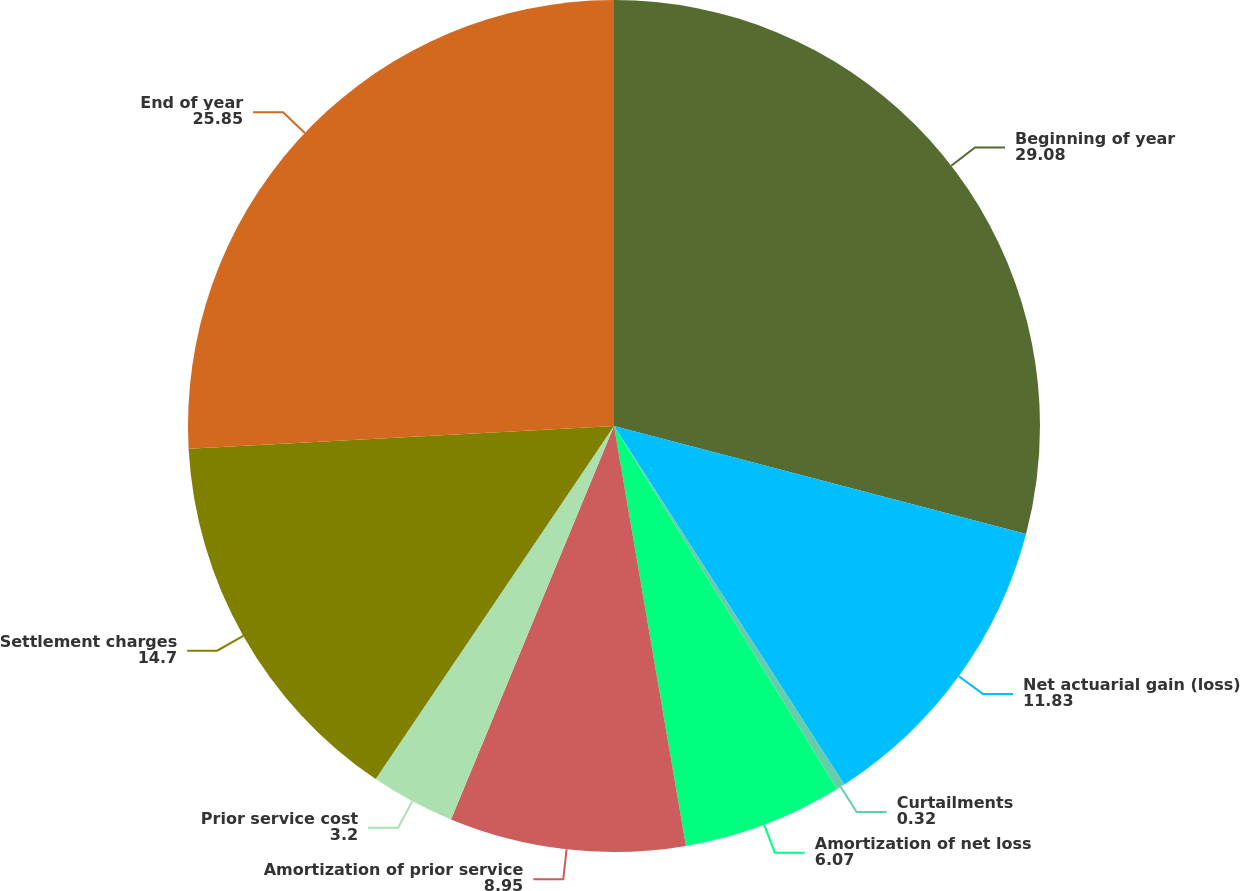Convert chart to OTSL. <chart><loc_0><loc_0><loc_500><loc_500><pie_chart><fcel>Beginning of year<fcel>Net actuarial gain (loss)<fcel>Curtailments<fcel>Amortization of net loss<fcel>Amortization of prior service<fcel>Prior service cost<fcel>Settlement charges<fcel>End of year<nl><fcel>29.08%<fcel>11.83%<fcel>0.32%<fcel>6.07%<fcel>8.95%<fcel>3.2%<fcel>14.7%<fcel>25.85%<nl></chart> 